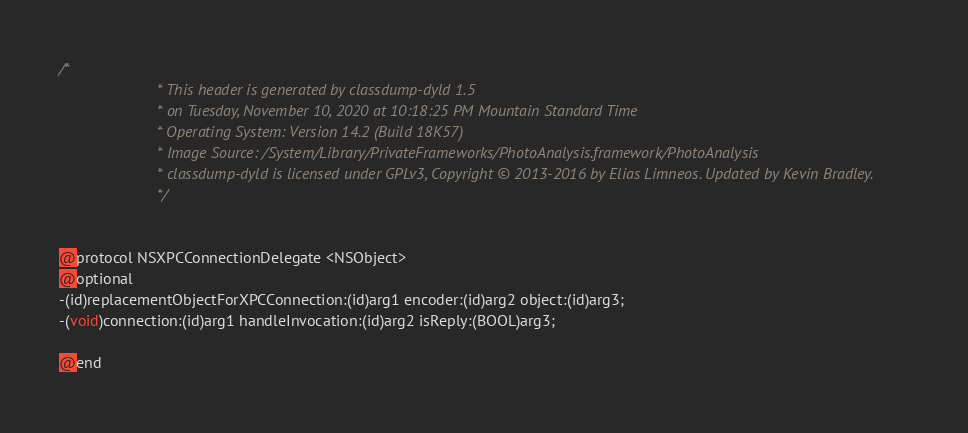Convert code to text. <code><loc_0><loc_0><loc_500><loc_500><_C_>/*
                       * This header is generated by classdump-dyld 1.5
                       * on Tuesday, November 10, 2020 at 10:18:25 PM Mountain Standard Time
                       * Operating System: Version 14.2 (Build 18K57)
                       * Image Source: /System/Library/PrivateFrameworks/PhotoAnalysis.framework/PhotoAnalysis
                       * classdump-dyld is licensed under GPLv3, Copyright © 2013-2016 by Elias Limneos. Updated by Kevin Bradley.
                       */


@protocol NSXPCConnectionDelegate <NSObject>
@optional
-(id)replacementObjectForXPCConnection:(id)arg1 encoder:(id)arg2 object:(id)arg3;
-(void)connection:(id)arg1 handleInvocation:(id)arg2 isReply:(BOOL)arg3;

@end

</code> 